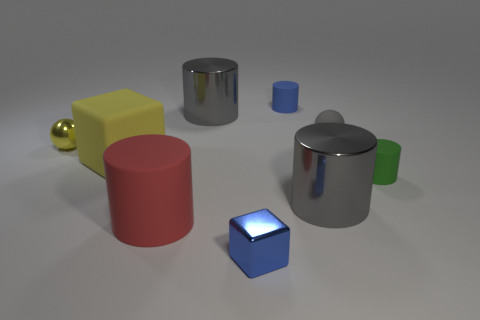Subtract all large gray metallic cylinders. How many cylinders are left? 3 Subtract all red cubes. How many gray cylinders are left? 2 Subtract 4 cylinders. How many cylinders are left? 1 Subtract all gray cylinders. How many cylinders are left? 3 Add 1 yellow matte objects. How many objects exist? 10 Subtract all red cylinders. Subtract all cyan cubes. How many cylinders are left? 4 Subtract all big cylinders. Subtract all small yellow shiny balls. How many objects are left? 5 Add 1 big blocks. How many big blocks are left? 2 Add 7 blue cylinders. How many blue cylinders exist? 8 Subtract 0 cyan cubes. How many objects are left? 9 